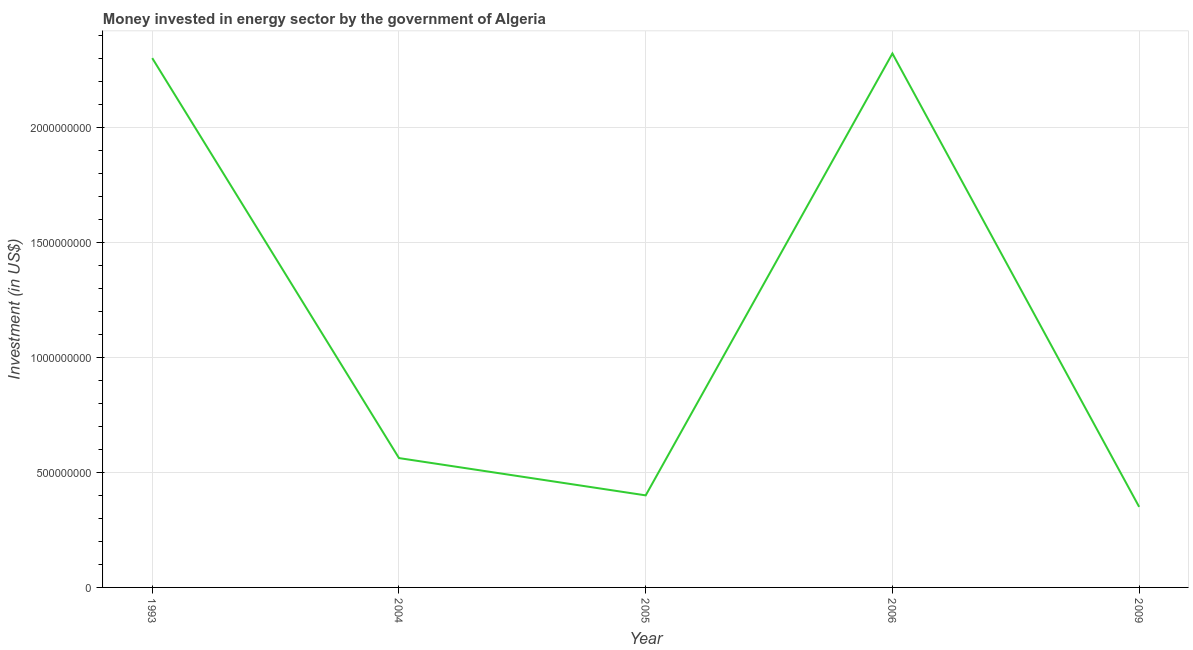What is the investment in energy in 2004?
Your answer should be very brief. 5.62e+08. Across all years, what is the maximum investment in energy?
Provide a succinct answer. 2.32e+09. Across all years, what is the minimum investment in energy?
Ensure brevity in your answer.  3.50e+08. In which year was the investment in energy maximum?
Ensure brevity in your answer.  2006. What is the sum of the investment in energy?
Offer a terse response. 5.93e+09. What is the difference between the investment in energy in 1993 and 2004?
Give a very brief answer. 1.74e+09. What is the average investment in energy per year?
Give a very brief answer. 1.19e+09. What is the median investment in energy?
Offer a very short reply. 5.62e+08. In how many years, is the investment in energy greater than 1100000000 US$?
Keep it short and to the point. 2. What is the ratio of the investment in energy in 2004 to that in 2005?
Give a very brief answer. 1.41. What is the difference between the highest and the lowest investment in energy?
Offer a terse response. 1.97e+09. How many lines are there?
Your response must be concise. 1. What is the difference between two consecutive major ticks on the Y-axis?
Ensure brevity in your answer.  5.00e+08. Are the values on the major ticks of Y-axis written in scientific E-notation?
Your answer should be compact. No. Does the graph contain grids?
Provide a short and direct response. Yes. What is the title of the graph?
Give a very brief answer. Money invested in energy sector by the government of Algeria. What is the label or title of the Y-axis?
Keep it short and to the point. Investment (in US$). What is the Investment (in US$) of 1993?
Ensure brevity in your answer.  2.30e+09. What is the Investment (in US$) in 2004?
Offer a very short reply. 5.62e+08. What is the Investment (in US$) of 2005?
Provide a short and direct response. 4.00e+08. What is the Investment (in US$) of 2006?
Offer a terse response. 2.32e+09. What is the Investment (in US$) in 2009?
Ensure brevity in your answer.  3.50e+08. What is the difference between the Investment (in US$) in 1993 and 2004?
Your response must be concise. 1.74e+09. What is the difference between the Investment (in US$) in 1993 and 2005?
Provide a succinct answer. 1.90e+09. What is the difference between the Investment (in US$) in 1993 and 2006?
Offer a very short reply. -2.00e+07. What is the difference between the Investment (in US$) in 1993 and 2009?
Your answer should be compact. 1.95e+09. What is the difference between the Investment (in US$) in 2004 and 2005?
Your answer should be compact. 1.62e+08. What is the difference between the Investment (in US$) in 2004 and 2006?
Ensure brevity in your answer.  -1.76e+09. What is the difference between the Investment (in US$) in 2004 and 2009?
Ensure brevity in your answer.  2.12e+08. What is the difference between the Investment (in US$) in 2005 and 2006?
Make the answer very short. -1.92e+09. What is the difference between the Investment (in US$) in 2005 and 2009?
Your answer should be compact. 5.00e+07. What is the difference between the Investment (in US$) in 2006 and 2009?
Make the answer very short. 1.97e+09. What is the ratio of the Investment (in US$) in 1993 to that in 2004?
Provide a short and direct response. 4.09. What is the ratio of the Investment (in US$) in 1993 to that in 2005?
Offer a terse response. 5.75. What is the ratio of the Investment (in US$) in 1993 to that in 2006?
Your answer should be very brief. 0.99. What is the ratio of the Investment (in US$) in 1993 to that in 2009?
Offer a very short reply. 6.57. What is the ratio of the Investment (in US$) in 2004 to that in 2005?
Offer a very short reply. 1.41. What is the ratio of the Investment (in US$) in 2004 to that in 2006?
Provide a short and direct response. 0.24. What is the ratio of the Investment (in US$) in 2004 to that in 2009?
Give a very brief answer. 1.61. What is the ratio of the Investment (in US$) in 2005 to that in 2006?
Keep it short and to the point. 0.17. What is the ratio of the Investment (in US$) in 2005 to that in 2009?
Ensure brevity in your answer.  1.14. What is the ratio of the Investment (in US$) in 2006 to that in 2009?
Your response must be concise. 6.63. 